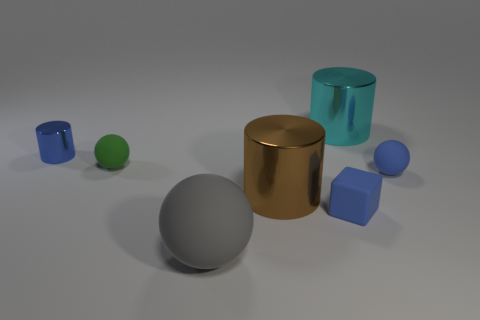Add 1 blue balls. How many objects exist? 8 Add 6 large brown things. How many large brown things are left? 7 Add 6 tiny cyan rubber blocks. How many tiny cyan rubber blocks exist? 6 Subtract all gray balls. How many balls are left? 2 Subtract all large shiny cylinders. How many cylinders are left? 1 Subtract 0 green cubes. How many objects are left? 7 Subtract all spheres. How many objects are left? 4 Subtract 3 cylinders. How many cylinders are left? 0 Subtract all purple cylinders. Subtract all yellow spheres. How many cylinders are left? 3 Subtract all yellow cylinders. How many green spheres are left? 1 